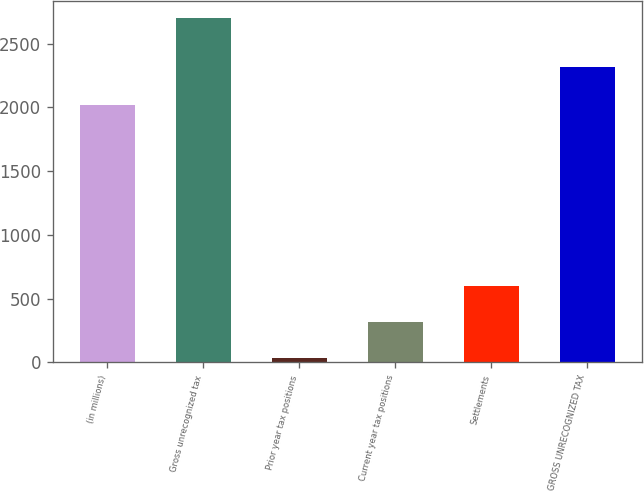<chart> <loc_0><loc_0><loc_500><loc_500><bar_chart><fcel>(in millions)<fcel>Gross unrecognized tax<fcel>Prior year tax positions<fcel>Current year tax positions<fcel>Settlements<fcel>GROSS UNRECOGNIZED TAX<nl><fcel>2016<fcel>2703<fcel>36<fcel>318.4<fcel>600.8<fcel>2319<nl></chart> 